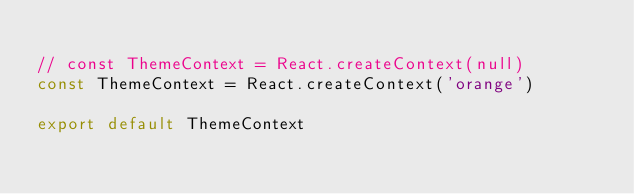Convert code to text. <code><loc_0><loc_0><loc_500><loc_500><_JavaScript_>
// const ThemeContext = React.createContext(null)
const ThemeContext = React.createContext('orange')

export default ThemeContext
</code> 